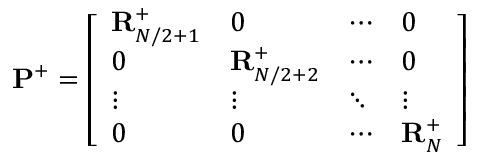<formula> <loc_0><loc_0><loc_500><loc_500>P ^ { + } = \left [ \begin{array} { l l l l } { R _ { N / 2 + 1 } ^ { + } } & { 0 } & { \cdots } & { 0 } \\ { 0 } & { R _ { N / 2 + 2 } ^ { + } } & { \cdots } & { 0 } \\ { \vdots } & { \vdots } & { \ddots } & { \vdots } \\ { 0 } & { 0 } & { \cdots } & { R _ { N } ^ { + } } \end{array} \right ]</formula> 